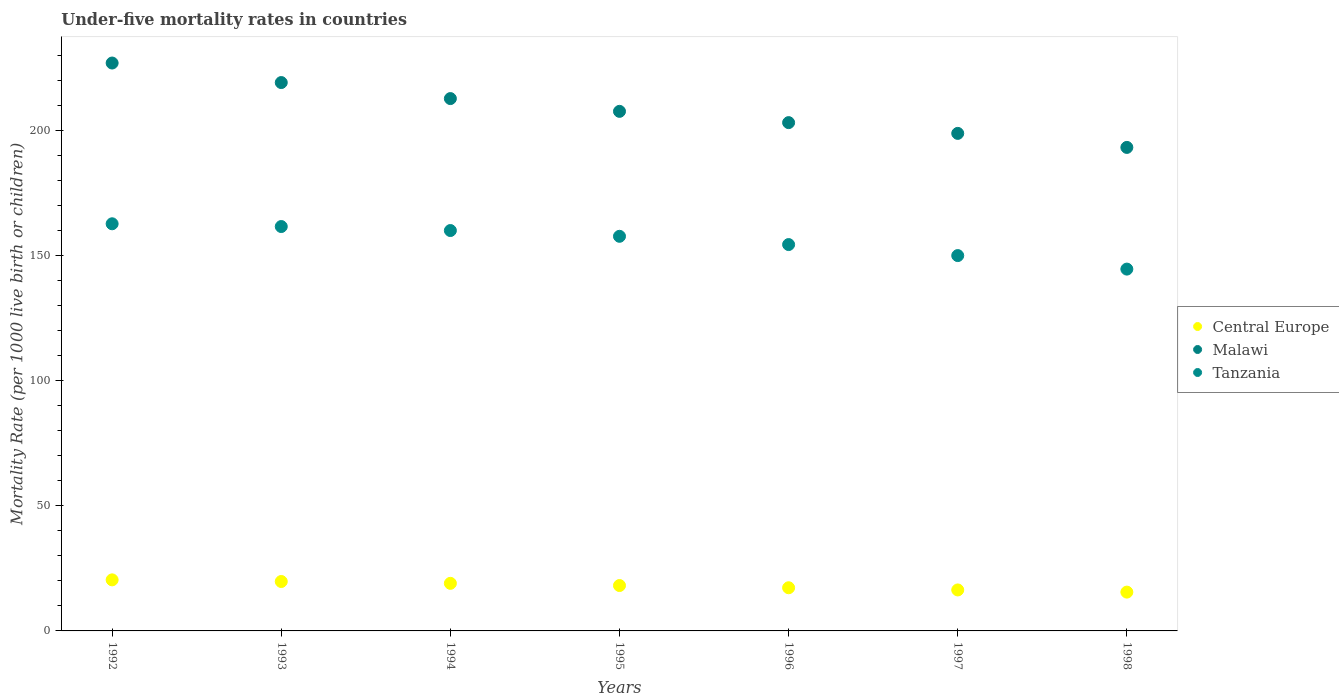How many different coloured dotlines are there?
Your answer should be very brief. 3. Is the number of dotlines equal to the number of legend labels?
Give a very brief answer. Yes. What is the under-five mortality rate in Central Europe in 1992?
Make the answer very short. 20.39. Across all years, what is the maximum under-five mortality rate in Tanzania?
Your answer should be very brief. 162.6. Across all years, what is the minimum under-five mortality rate in Tanzania?
Ensure brevity in your answer.  144.5. What is the total under-five mortality rate in Malawi in the graph?
Offer a very short reply. 1460.7. What is the difference between the under-five mortality rate in Central Europe in 1995 and that in 1996?
Keep it short and to the point. 0.89. What is the difference between the under-five mortality rate in Tanzania in 1997 and the under-five mortality rate in Malawi in 1996?
Your answer should be very brief. -53.1. What is the average under-five mortality rate in Tanzania per year?
Make the answer very short. 155.76. In the year 1995, what is the difference between the under-five mortality rate in Central Europe and under-five mortality rate in Malawi?
Your answer should be very brief. -189.37. In how many years, is the under-five mortality rate in Central Europe greater than 50?
Make the answer very short. 0. What is the ratio of the under-five mortality rate in Central Europe in 1995 to that in 1996?
Provide a succinct answer. 1.05. Is the difference between the under-five mortality rate in Central Europe in 1992 and 1998 greater than the difference between the under-five mortality rate in Malawi in 1992 and 1998?
Provide a succinct answer. No. What is the difference between the highest and the second highest under-five mortality rate in Malawi?
Keep it short and to the point. 7.8. What is the difference between the highest and the lowest under-five mortality rate in Central Europe?
Make the answer very short. 4.89. In how many years, is the under-five mortality rate in Malawi greater than the average under-five mortality rate in Malawi taken over all years?
Ensure brevity in your answer.  3. Is the sum of the under-five mortality rate in Tanzania in 1992 and 1994 greater than the maximum under-five mortality rate in Central Europe across all years?
Offer a terse response. Yes. Is the under-five mortality rate in Malawi strictly less than the under-five mortality rate in Central Europe over the years?
Make the answer very short. No. How many dotlines are there?
Your answer should be compact. 3. How many years are there in the graph?
Make the answer very short. 7. Does the graph contain any zero values?
Your answer should be very brief. No. What is the title of the graph?
Keep it short and to the point. Under-five mortality rates in countries. What is the label or title of the X-axis?
Your answer should be very brief. Years. What is the label or title of the Y-axis?
Keep it short and to the point. Mortality Rate (per 1000 live birth or children). What is the Mortality Rate (per 1000 live birth or children) in Central Europe in 1992?
Your answer should be compact. 20.39. What is the Mortality Rate (per 1000 live birth or children) in Malawi in 1992?
Make the answer very short. 226.8. What is the Mortality Rate (per 1000 live birth or children) in Tanzania in 1992?
Your answer should be compact. 162.6. What is the Mortality Rate (per 1000 live birth or children) in Central Europe in 1993?
Offer a terse response. 19.73. What is the Mortality Rate (per 1000 live birth or children) of Malawi in 1993?
Ensure brevity in your answer.  219. What is the Mortality Rate (per 1000 live birth or children) of Tanzania in 1993?
Provide a succinct answer. 161.5. What is the Mortality Rate (per 1000 live birth or children) in Central Europe in 1994?
Provide a short and direct response. 19. What is the Mortality Rate (per 1000 live birth or children) of Malawi in 1994?
Offer a terse response. 212.6. What is the Mortality Rate (per 1000 live birth or children) in Tanzania in 1994?
Make the answer very short. 159.9. What is the Mortality Rate (per 1000 live birth or children) in Central Europe in 1995?
Offer a very short reply. 18.13. What is the Mortality Rate (per 1000 live birth or children) of Malawi in 1995?
Keep it short and to the point. 207.5. What is the Mortality Rate (per 1000 live birth or children) in Tanzania in 1995?
Offer a terse response. 157.6. What is the Mortality Rate (per 1000 live birth or children) in Central Europe in 1996?
Ensure brevity in your answer.  17.24. What is the Mortality Rate (per 1000 live birth or children) of Malawi in 1996?
Offer a very short reply. 203. What is the Mortality Rate (per 1000 live birth or children) of Tanzania in 1996?
Provide a short and direct response. 154.3. What is the Mortality Rate (per 1000 live birth or children) of Central Europe in 1997?
Your answer should be very brief. 16.37. What is the Mortality Rate (per 1000 live birth or children) of Malawi in 1997?
Keep it short and to the point. 198.7. What is the Mortality Rate (per 1000 live birth or children) in Tanzania in 1997?
Give a very brief answer. 149.9. What is the Mortality Rate (per 1000 live birth or children) in Central Europe in 1998?
Give a very brief answer. 15.5. What is the Mortality Rate (per 1000 live birth or children) in Malawi in 1998?
Give a very brief answer. 193.1. What is the Mortality Rate (per 1000 live birth or children) of Tanzania in 1998?
Make the answer very short. 144.5. Across all years, what is the maximum Mortality Rate (per 1000 live birth or children) in Central Europe?
Offer a terse response. 20.39. Across all years, what is the maximum Mortality Rate (per 1000 live birth or children) in Malawi?
Keep it short and to the point. 226.8. Across all years, what is the maximum Mortality Rate (per 1000 live birth or children) of Tanzania?
Your answer should be very brief. 162.6. Across all years, what is the minimum Mortality Rate (per 1000 live birth or children) in Central Europe?
Your response must be concise. 15.5. Across all years, what is the minimum Mortality Rate (per 1000 live birth or children) in Malawi?
Keep it short and to the point. 193.1. Across all years, what is the minimum Mortality Rate (per 1000 live birth or children) in Tanzania?
Give a very brief answer. 144.5. What is the total Mortality Rate (per 1000 live birth or children) in Central Europe in the graph?
Make the answer very short. 126.36. What is the total Mortality Rate (per 1000 live birth or children) of Malawi in the graph?
Your answer should be very brief. 1460.7. What is the total Mortality Rate (per 1000 live birth or children) in Tanzania in the graph?
Your answer should be compact. 1090.3. What is the difference between the Mortality Rate (per 1000 live birth or children) of Central Europe in 1992 and that in 1993?
Provide a succinct answer. 0.66. What is the difference between the Mortality Rate (per 1000 live birth or children) in Malawi in 1992 and that in 1993?
Your answer should be compact. 7.8. What is the difference between the Mortality Rate (per 1000 live birth or children) in Tanzania in 1992 and that in 1993?
Provide a short and direct response. 1.1. What is the difference between the Mortality Rate (per 1000 live birth or children) of Central Europe in 1992 and that in 1994?
Your answer should be compact. 1.39. What is the difference between the Mortality Rate (per 1000 live birth or children) in Central Europe in 1992 and that in 1995?
Offer a terse response. 2.27. What is the difference between the Mortality Rate (per 1000 live birth or children) in Malawi in 1992 and that in 1995?
Keep it short and to the point. 19.3. What is the difference between the Mortality Rate (per 1000 live birth or children) in Central Europe in 1992 and that in 1996?
Give a very brief answer. 3.15. What is the difference between the Mortality Rate (per 1000 live birth or children) of Malawi in 1992 and that in 1996?
Your answer should be very brief. 23.8. What is the difference between the Mortality Rate (per 1000 live birth or children) in Tanzania in 1992 and that in 1996?
Keep it short and to the point. 8.3. What is the difference between the Mortality Rate (per 1000 live birth or children) in Central Europe in 1992 and that in 1997?
Ensure brevity in your answer.  4.03. What is the difference between the Mortality Rate (per 1000 live birth or children) in Malawi in 1992 and that in 1997?
Keep it short and to the point. 28.1. What is the difference between the Mortality Rate (per 1000 live birth or children) of Central Europe in 1992 and that in 1998?
Offer a terse response. 4.89. What is the difference between the Mortality Rate (per 1000 live birth or children) of Malawi in 1992 and that in 1998?
Ensure brevity in your answer.  33.7. What is the difference between the Mortality Rate (per 1000 live birth or children) of Central Europe in 1993 and that in 1994?
Make the answer very short. 0.73. What is the difference between the Mortality Rate (per 1000 live birth or children) of Tanzania in 1993 and that in 1994?
Ensure brevity in your answer.  1.6. What is the difference between the Mortality Rate (per 1000 live birth or children) of Central Europe in 1993 and that in 1995?
Offer a terse response. 1.61. What is the difference between the Mortality Rate (per 1000 live birth or children) of Malawi in 1993 and that in 1995?
Your answer should be very brief. 11.5. What is the difference between the Mortality Rate (per 1000 live birth or children) of Central Europe in 1993 and that in 1996?
Give a very brief answer. 2.5. What is the difference between the Mortality Rate (per 1000 live birth or children) in Central Europe in 1993 and that in 1997?
Your answer should be compact. 3.37. What is the difference between the Mortality Rate (per 1000 live birth or children) in Malawi in 1993 and that in 1997?
Ensure brevity in your answer.  20.3. What is the difference between the Mortality Rate (per 1000 live birth or children) in Tanzania in 1993 and that in 1997?
Your answer should be very brief. 11.6. What is the difference between the Mortality Rate (per 1000 live birth or children) of Central Europe in 1993 and that in 1998?
Offer a very short reply. 4.24. What is the difference between the Mortality Rate (per 1000 live birth or children) in Malawi in 1993 and that in 1998?
Your response must be concise. 25.9. What is the difference between the Mortality Rate (per 1000 live birth or children) of Central Europe in 1994 and that in 1995?
Ensure brevity in your answer.  0.88. What is the difference between the Mortality Rate (per 1000 live birth or children) in Tanzania in 1994 and that in 1995?
Your response must be concise. 2.3. What is the difference between the Mortality Rate (per 1000 live birth or children) of Central Europe in 1994 and that in 1996?
Your answer should be compact. 1.77. What is the difference between the Mortality Rate (per 1000 live birth or children) of Tanzania in 1994 and that in 1996?
Ensure brevity in your answer.  5.6. What is the difference between the Mortality Rate (per 1000 live birth or children) in Central Europe in 1994 and that in 1997?
Offer a terse response. 2.64. What is the difference between the Mortality Rate (per 1000 live birth or children) in Malawi in 1994 and that in 1997?
Give a very brief answer. 13.9. What is the difference between the Mortality Rate (per 1000 live birth or children) in Tanzania in 1994 and that in 1997?
Make the answer very short. 10. What is the difference between the Mortality Rate (per 1000 live birth or children) of Central Europe in 1994 and that in 1998?
Give a very brief answer. 3.5. What is the difference between the Mortality Rate (per 1000 live birth or children) in Malawi in 1994 and that in 1998?
Make the answer very short. 19.5. What is the difference between the Mortality Rate (per 1000 live birth or children) in Central Europe in 1995 and that in 1996?
Make the answer very short. 0.89. What is the difference between the Mortality Rate (per 1000 live birth or children) of Malawi in 1995 and that in 1996?
Provide a succinct answer. 4.5. What is the difference between the Mortality Rate (per 1000 live birth or children) of Tanzania in 1995 and that in 1996?
Provide a succinct answer. 3.3. What is the difference between the Mortality Rate (per 1000 live birth or children) in Central Europe in 1995 and that in 1997?
Provide a short and direct response. 1.76. What is the difference between the Mortality Rate (per 1000 live birth or children) of Central Europe in 1995 and that in 1998?
Give a very brief answer. 2.63. What is the difference between the Mortality Rate (per 1000 live birth or children) in Tanzania in 1995 and that in 1998?
Ensure brevity in your answer.  13.1. What is the difference between the Mortality Rate (per 1000 live birth or children) in Central Europe in 1996 and that in 1997?
Offer a terse response. 0.87. What is the difference between the Mortality Rate (per 1000 live birth or children) in Tanzania in 1996 and that in 1997?
Your response must be concise. 4.4. What is the difference between the Mortality Rate (per 1000 live birth or children) of Central Europe in 1996 and that in 1998?
Your answer should be very brief. 1.74. What is the difference between the Mortality Rate (per 1000 live birth or children) in Tanzania in 1996 and that in 1998?
Make the answer very short. 9.8. What is the difference between the Mortality Rate (per 1000 live birth or children) of Central Europe in 1997 and that in 1998?
Provide a short and direct response. 0.87. What is the difference between the Mortality Rate (per 1000 live birth or children) in Malawi in 1997 and that in 1998?
Provide a short and direct response. 5.6. What is the difference between the Mortality Rate (per 1000 live birth or children) of Tanzania in 1997 and that in 1998?
Offer a very short reply. 5.4. What is the difference between the Mortality Rate (per 1000 live birth or children) of Central Europe in 1992 and the Mortality Rate (per 1000 live birth or children) of Malawi in 1993?
Give a very brief answer. -198.61. What is the difference between the Mortality Rate (per 1000 live birth or children) in Central Europe in 1992 and the Mortality Rate (per 1000 live birth or children) in Tanzania in 1993?
Your response must be concise. -141.11. What is the difference between the Mortality Rate (per 1000 live birth or children) in Malawi in 1992 and the Mortality Rate (per 1000 live birth or children) in Tanzania in 1993?
Ensure brevity in your answer.  65.3. What is the difference between the Mortality Rate (per 1000 live birth or children) of Central Europe in 1992 and the Mortality Rate (per 1000 live birth or children) of Malawi in 1994?
Offer a very short reply. -192.21. What is the difference between the Mortality Rate (per 1000 live birth or children) of Central Europe in 1992 and the Mortality Rate (per 1000 live birth or children) of Tanzania in 1994?
Your response must be concise. -139.51. What is the difference between the Mortality Rate (per 1000 live birth or children) in Malawi in 1992 and the Mortality Rate (per 1000 live birth or children) in Tanzania in 1994?
Ensure brevity in your answer.  66.9. What is the difference between the Mortality Rate (per 1000 live birth or children) of Central Europe in 1992 and the Mortality Rate (per 1000 live birth or children) of Malawi in 1995?
Your response must be concise. -187.11. What is the difference between the Mortality Rate (per 1000 live birth or children) in Central Europe in 1992 and the Mortality Rate (per 1000 live birth or children) in Tanzania in 1995?
Provide a succinct answer. -137.21. What is the difference between the Mortality Rate (per 1000 live birth or children) in Malawi in 1992 and the Mortality Rate (per 1000 live birth or children) in Tanzania in 1995?
Provide a short and direct response. 69.2. What is the difference between the Mortality Rate (per 1000 live birth or children) of Central Europe in 1992 and the Mortality Rate (per 1000 live birth or children) of Malawi in 1996?
Your answer should be very brief. -182.61. What is the difference between the Mortality Rate (per 1000 live birth or children) of Central Europe in 1992 and the Mortality Rate (per 1000 live birth or children) of Tanzania in 1996?
Give a very brief answer. -133.91. What is the difference between the Mortality Rate (per 1000 live birth or children) of Malawi in 1992 and the Mortality Rate (per 1000 live birth or children) of Tanzania in 1996?
Keep it short and to the point. 72.5. What is the difference between the Mortality Rate (per 1000 live birth or children) in Central Europe in 1992 and the Mortality Rate (per 1000 live birth or children) in Malawi in 1997?
Offer a very short reply. -178.31. What is the difference between the Mortality Rate (per 1000 live birth or children) in Central Europe in 1992 and the Mortality Rate (per 1000 live birth or children) in Tanzania in 1997?
Your answer should be compact. -129.51. What is the difference between the Mortality Rate (per 1000 live birth or children) of Malawi in 1992 and the Mortality Rate (per 1000 live birth or children) of Tanzania in 1997?
Your response must be concise. 76.9. What is the difference between the Mortality Rate (per 1000 live birth or children) in Central Europe in 1992 and the Mortality Rate (per 1000 live birth or children) in Malawi in 1998?
Your response must be concise. -172.71. What is the difference between the Mortality Rate (per 1000 live birth or children) of Central Europe in 1992 and the Mortality Rate (per 1000 live birth or children) of Tanzania in 1998?
Your answer should be very brief. -124.11. What is the difference between the Mortality Rate (per 1000 live birth or children) of Malawi in 1992 and the Mortality Rate (per 1000 live birth or children) of Tanzania in 1998?
Keep it short and to the point. 82.3. What is the difference between the Mortality Rate (per 1000 live birth or children) of Central Europe in 1993 and the Mortality Rate (per 1000 live birth or children) of Malawi in 1994?
Your answer should be very brief. -192.87. What is the difference between the Mortality Rate (per 1000 live birth or children) in Central Europe in 1993 and the Mortality Rate (per 1000 live birth or children) in Tanzania in 1994?
Your response must be concise. -140.17. What is the difference between the Mortality Rate (per 1000 live birth or children) of Malawi in 1993 and the Mortality Rate (per 1000 live birth or children) of Tanzania in 1994?
Your response must be concise. 59.1. What is the difference between the Mortality Rate (per 1000 live birth or children) of Central Europe in 1993 and the Mortality Rate (per 1000 live birth or children) of Malawi in 1995?
Offer a terse response. -187.77. What is the difference between the Mortality Rate (per 1000 live birth or children) in Central Europe in 1993 and the Mortality Rate (per 1000 live birth or children) in Tanzania in 1995?
Your answer should be very brief. -137.87. What is the difference between the Mortality Rate (per 1000 live birth or children) in Malawi in 1993 and the Mortality Rate (per 1000 live birth or children) in Tanzania in 1995?
Keep it short and to the point. 61.4. What is the difference between the Mortality Rate (per 1000 live birth or children) in Central Europe in 1993 and the Mortality Rate (per 1000 live birth or children) in Malawi in 1996?
Give a very brief answer. -183.27. What is the difference between the Mortality Rate (per 1000 live birth or children) in Central Europe in 1993 and the Mortality Rate (per 1000 live birth or children) in Tanzania in 1996?
Give a very brief answer. -134.57. What is the difference between the Mortality Rate (per 1000 live birth or children) in Malawi in 1993 and the Mortality Rate (per 1000 live birth or children) in Tanzania in 1996?
Provide a short and direct response. 64.7. What is the difference between the Mortality Rate (per 1000 live birth or children) in Central Europe in 1993 and the Mortality Rate (per 1000 live birth or children) in Malawi in 1997?
Your answer should be compact. -178.97. What is the difference between the Mortality Rate (per 1000 live birth or children) in Central Europe in 1993 and the Mortality Rate (per 1000 live birth or children) in Tanzania in 1997?
Your answer should be compact. -130.17. What is the difference between the Mortality Rate (per 1000 live birth or children) of Malawi in 1993 and the Mortality Rate (per 1000 live birth or children) of Tanzania in 1997?
Provide a succinct answer. 69.1. What is the difference between the Mortality Rate (per 1000 live birth or children) in Central Europe in 1993 and the Mortality Rate (per 1000 live birth or children) in Malawi in 1998?
Ensure brevity in your answer.  -173.37. What is the difference between the Mortality Rate (per 1000 live birth or children) in Central Europe in 1993 and the Mortality Rate (per 1000 live birth or children) in Tanzania in 1998?
Give a very brief answer. -124.77. What is the difference between the Mortality Rate (per 1000 live birth or children) of Malawi in 1993 and the Mortality Rate (per 1000 live birth or children) of Tanzania in 1998?
Make the answer very short. 74.5. What is the difference between the Mortality Rate (per 1000 live birth or children) of Central Europe in 1994 and the Mortality Rate (per 1000 live birth or children) of Malawi in 1995?
Offer a very short reply. -188.5. What is the difference between the Mortality Rate (per 1000 live birth or children) of Central Europe in 1994 and the Mortality Rate (per 1000 live birth or children) of Tanzania in 1995?
Your answer should be compact. -138.6. What is the difference between the Mortality Rate (per 1000 live birth or children) in Malawi in 1994 and the Mortality Rate (per 1000 live birth or children) in Tanzania in 1995?
Your response must be concise. 55. What is the difference between the Mortality Rate (per 1000 live birth or children) of Central Europe in 1994 and the Mortality Rate (per 1000 live birth or children) of Malawi in 1996?
Your answer should be very brief. -184. What is the difference between the Mortality Rate (per 1000 live birth or children) of Central Europe in 1994 and the Mortality Rate (per 1000 live birth or children) of Tanzania in 1996?
Keep it short and to the point. -135.3. What is the difference between the Mortality Rate (per 1000 live birth or children) in Malawi in 1994 and the Mortality Rate (per 1000 live birth or children) in Tanzania in 1996?
Your response must be concise. 58.3. What is the difference between the Mortality Rate (per 1000 live birth or children) of Central Europe in 1994 and the Mortality Rate (per 1000 live birth or children) of Malawi in 1997?
Give a very brief answer. -179.7. What is the difference between the Mortality Rate (per 1000 live birth or children) of Central Europe in 1994 and the Mortality Rate (per 1000 live birth or children) of Tanzania in 1997?
Your answer should be compact. -130.9. What is the difference between the Mortality Rate (per 1000 live birth or children) of Malawi in 1994 and the Mortality Rate (per 1000 live birth or children) of Tanzania in 1997?
Your response must be concise. 62.7. What is the difference between the Mortality Rate (per 1000 live birth or children) in Central Europe in 1994 and the Mortality Rate (per 1000 live birth or children) in Malawi in 1998?
Provide a succinct answer. -174.1. What is the difference between the Mortality Rate (per 1000 live birth or children) of Central Europe in 1994 and the Mortality Rate (per 1000 live birth or children) of Tanzania in 1998?
Make the answer very short. -125.5. What is the difference between the Mortality Rate (per 1000 live birth or children) of Malawi in 1994 and the Mortality Rate (per 1000 live birth or children) of Tanzania in 1998?
Give a very brief answer. 68.1. What is the difference between the Mortality Rate (per 1000 live birth or children) of Central Europe in 1995 and the Mortality Rate (per 1000 live birth or children) of Malawi in 1996?
Give a very brief answer. -184.87. What is the difference between the Mortality Rate (per 1000 live birth or children) in Central Europe in 1995 and the Mortality Rate (per 1000 live birth or children) in Tanzania in 1996?
Keep it short and to the point. -136.17. What is the difference between the Mortality Rate (per 1000 live birth or children) of Malawi in 1995 and the Mortality Rate (per 1000 live birth or children) of Tanzania in 1996?
Ensure brevity in your answer.  53.2. What is the difference between the Mortality Rate (per 1000 live birth or children) of Central Europe in 1995 and the Mortality Rate (per 1000 live birth or children) of Malawi in 1997?
Give a very brief answer. -180.57. What is the difference between the Mortality Rate (per 1000 live birth or children) of Central Europe in 1995 and the Mortality Rate (per 1000 live birth or children) of Tanzania in 1997?
Keep it short and to the point. -131.77. What is the difference between the Mortality Rate (per 1000 live birth or children) of Malawi in 1995 and the Mortality Rate (per 1000 live birth or children) of Tanzania in 1997?
Keep it short and to the point. 57.6. What is the difference between the Mortality Rate (per 1000 live birth or children) of Central Europe in 1995 and the Mortality Rate (per 1000 live birth or children) of Malawi in 1998?
Your answer should be very brief. -174.97. What is the difference between the Mortality Rate (per 1000 live birth or children) of Central Europe in 1995 and the Mortality Rate (per 1000 live birth or children) of Tanzania in 1998?
Your answer should be very brief. -126.37. What is the difference between the Mortality Rate (per 1000 live birth or children) in Malawi in 1995 and the Mortality Rate (per 1000 live birth or children) in Tanzania in 1998?
Keep it short and to the point. 63. What is the difference between the Mortality Rate (per 1000 live birth or children) in Central Europe in 1996 and the Mortality Rate (per 1000 live birth or children) in Malawi in 1997?
Ensure brevity in your answer.  -181.46. What is the difference between the Mortality Rate (per 1000 live birth or children) in Central Europe in 1996 and the Mortality Rate (per 1000 live birth or children) in Tanzania in 1997?
Provide a short and direct response. -132.66. What is the difference between the Mortality Rate (per 1000 live birth or children) in Malawi in 1996 and the Mortality Rate (per 1000 live birth or children) in Tanzania in 1997?
Offer a terse response. 53.1. What is the difference between the Mortality Rate (per 1000 live birth or children) in Central Europe in 1996 and the Mortality Rate (per 1000 live birth or children) in Malawi in 1998?
Provide a short and direct response. -175.86. What is the difference between the Mortality Rate (per 1000 live birth or children) in Central Europe in 1996 and the Mortality Rate (per 1000 live birth or children) in Tanzania in 1998?
Ensure brevity in your answer.  -127.26. What is the difference between the Mortality Rate (per 1000 live birth or children) in Malawi in 1996 and the Mortality Rate (per 1000 live birth or children) in Tanzania in 1998?
Provide a succinct answer. 58.5. What is the difference between the Mortality Rate (per 1000 live birth or children) in Central Europe in 1997 and the Mortality Rate (per 1000 live birth or children) in Malawi in 1998?
Give a very brief answer. -176.73. What is the difference between the Mortality Rate (per 1000 live birth or children) in Central Europe in 1997 and the Mortality Rate (per 1000 live birth or children) in Tanzania in 1998?
Ensure brevity in your answer.  -128.13. What is the difference between the Mortality Rate (per 1000 live birth or children) of Malawi in 1997 and the Mortality Rate (per 1000 live birth or children) of Tanzania in 1998?
Offer a very short reply. 54.2. What is the average Mortality Rate (per 1000 live birth or children) in Central Europe per year?
Offer a terse response. 18.05. What is the average Mortality Rate (per 1000 live birth or children) of Malawi per year?
Ensure brevity in your answer.  208.67. What is the average Mortality Rate (per 1000 live birth or children) in Tanzania per year?
Provide a succinct answer. 155.76. In the year 1992, what is the difference between the Mortality Rate (per 1000 live birth or children) in Central Europe and Mortality Rate (per 1000 live birth or children) in Malawi?
Ensure brevity in your answer.  -206.41. In the year 1992, what is the difference between the Mortality Rate (per 1000 live birth or children) of Central Europe and Mortality Rate (per 1000 live birth or children) of Tanzania?
Your response must be concise. -142.21. In the year 1992, what is the difference between the Mortality Rate (per 1000 live birth or children) of Malawi and Mortality Rate (per 1000 live birth or children) of Tanzania?
Your answer should be very brief. 64.2. In the year 1993, what is the difference between the Mortality Rate (per 1000 live birth or children) in Central Europe and Mortality Rate (per 1000 live birth or children) in Malawi?
Your answer should be compact. -199.27. In the year 1993, what is the difference between the Mortality Rate (per 1000 live birth or children) of Central Europe and Mortality Rate (per 1000 live birth or children) of Tanzania?
Make the answer very short. -141.77. In the year 1993, what is the difference between the Mortality Rate (per 1000 live birth or children) in Malawi and Mortality Rate (per 1000 live birth or children) in Tanzania?
Provide a succinct answer. 57.5. In the year 1994, what is the difference between the Mortality Rate (per 1000 live birth or children) of Central Europe and Mortality Rate (per 1000 live birth or children) of Malawi?
Offer a very short reply. -193.6. In the year 1994, what is the difference between the Mortality Rate (per 1000 live birth or children) of Central Europe and Mortality Rate (per 1000 live birth or children) of Tanzania?
Offer a very short reply. -140.9. In the year 1994, what is the difference between the Mortality Rate (per 1000 live birth or children) in Malawi and Mortality Rate (per 1000 live birth or children) in Tanzania?
Ensure brevity in your answer.  52.7. In the year 1995, what is the difference between the Mortality Rate (per 1000 live birth or children) in Central Europe and Mortality Rate (per 1000 live birth or children) in Malawi?
Offer a very short reply. -189.37. In the year 1995, what is the difference between the Mortality Rate (per 1000 live birth or children) of Central Europe and Mortality Rate (per 1000 live birth or children) of Tanzania?
Give a very brief answer. -139.47. In the year 1995, what is the difference between the Mortality Rate (per 1000 live birth or children) in Malawi and Mortality Rate (per 1000 live birth or children) in Tanzania?
Give a very brief answer. 49.9. In the year 1996, what is the difference between the Mortality Rate (per 1000 live birth or children) in Central Europe and Mortality Rate (per 1000 live birth or children) in Malawi?
Ensure brevity in your answer.  -185.76. In the year 1996, what is the difference between the Mortality Rate (per 1000 live birth or children) in Central Europe and Mortality Rate (per 1000 live birth or children) in Tanzania?
Offer a terse response. -137.06. In the year 1996, what is the difference between the Mortality Rate (per 1000 live birth or children) of Malawi and Mortality Rate (per 1000 live birth or children) of Tanzania?
Offer a very short reply. 48.7. In the year 1997, what is the difference between the Mortality Rate (per 1000 live birth or children) in Central Europe and Mortality Rate (per 1000 live birth or children) in Malawi?
Your answer should be very brief. -182.33. In the year 1997, what is the difference between the Mortality Rate (per 1000 live birth or children) of Central Europe and Mortality Rate (per 1000 live birth or children) of Tanzania?
Your response must be concise. -133.53. In the year 1997, what is the difference between the Mortality Rate (per 1000 live birth or children) of Malawi and Mortality Rate (per 1000 live birth or children) of Tanzania?
Provide a succinct answer. 48.8. In the year 1998, what is the difference between the Mortality Rate (per 1000 live birth or children) in Central Europe and Mortality Rate (per 1000 live birth or children) in Malawi?
Your answer should be very brief. -177.6. In the year 1998, what is the difference between the Mortality Rate (per 1000 live birth or children) in Central Europe and Mortality Rate (per 1000 live birth or children) in Tanzania?
Offer a very short reply. -129. In the year 1998, what is the difference between the Mortality Rate (per 1000 live birth or children) of Malawi and Mortality Rate (per 1000 live birth or children) of Tanzania?
Provide a short and direct response. 48.6. What is the ratio of the Mortality Rate (per 1000 live birth or children) of Malawi in 1992 to that in 1993?
Your answer should be very brief. 1.04. What is the ratio of the Mortality Rate (per 1000 live birth or children) of Tanzania in 1992 to that in 1993?
Ensure brevity in your answer.  1.01. What is the ratio of the Mortality Rate (per 1000 live birth or children) of Central Europe in 1992 to that in 1994?
Your answer should be very brief. 1.07. What is the ratio of the Mortality Rate (per 1000 live birth or children) of Malawi in 1992 to that in 1994?
Offer a very short reply. 1.07. What is the ratio of the Mortality Rate (per 1000 live birth or children) in Tanzania in 1992 to that in 1994?
Make the answer very short. 1.02. What is the ratio of the Mortality Rate (per 1000 live birth or children) of Malawi in 1992 to that in 1995?
Your response must be concise. 1.09. What is the ratio of the Mortality Rate (per 1000 live birth or children) in Tanzania in 1992 to that in 1995?
Offer a very short reply. 1.03. What is the ratio of the Mortality Rate (per 1000 live birth or children) in Central Europe in 1992 to that in 1996?
Give a very brief answer. 1.18. What is the ratio of the Mortality Rate (per 1000 live birth or children) of Malawi in 1992 to that in 1996?
Give a very brief answer. 1.12. What is the ratio of the Mortality Rate (per 1000 live birth or children) of Tanzania in 1992 to that in 1996?
Your answer should be very brief. 1.05. What is the ratio of the Mortality Rate (per 1000 live birth or children) in Central Europe in 1992 to that in 1997?
Your response must be concise. 1.25. What is the ratio of the Mortality Rate (per 1000 live birth or children) of Malawi in 1992 to that in 1997?
Make the answer very short. 1.14. What is the ratio of the Mortality Rate (per 1000 live birth or children) of Tanzania in 1992 to that in 1997?
Your answer should be very brief. 1.08. What is the ratio of the Mortality Rate (per 1000 live birth or children) of Central Europe in 1992 to that in 1998?
Your response must be concise. 1.32. What is the ratio of the Mortality Rate (per 1000 live birth or children) in Malawi in 1992 to that in 1998?
Your answer should be compact. 1.17. What is the ratio of the Mortality Rate (per 1000 live birth or children) in Tanzania in 1992 to that in 1998?
Provide a short and direct response. 1.13. What is the ratio of the Mortality Rate (per 1000 live birth or children) in Malawi in 1993 to that in 1994?
Make the answer very short. 1.03. What is the ratio of the Mortality Rate (per 1000 live birth or children) in Tanzania in 1993 to that in 1994?
Keep it short and to the point. 1.01. What is the ratio of the Mortality Rate (per 1000 live birth or children) in Central Europe in 1993 to that in 1995?
Ensure brevity in your answer.  1.09. What is the ratio of the Mortality Rate (per 1000 live birth or children) in Malawi in 1993 to that in 1995?
Provide a succinct answer. 1.06. What is the ratio of the Mortality Rate (per 1000 live birth or children) in Tanzania in 1993 to that in 1995?
Ensure brevity in your answer.  1.02. What is the ratio of the Mortality Rate (per 1000 live birth or children) of Central Europe in 1993 to that in 1996?
Offer a very short reply. 1.14. What is the ratio of the Mortality Rate (per 1000 live birth or children) of Malawi in 1993 to that in 1996?
Offer a terse response. 1.08. What is the ratio of the Mortality Rate (per 1000 live birth or children) in Tanzania in 1993 to that in 1996?
Your answer should be very brief. 1.05. What is the ratio of the Mortality Rate (per 1000 live birth or children) of Central Europe in 1993 to that in 1997?
Your answer should be compact. 1.21. What is the ratio of the Mortality Rate (per 1000 live birth or children) of Malawi in 1993 to that in 1997?
Your answer should be very brief. 1.1. What is the ratio of the Mortality Rate (per 1000 live birth or children) of Tanzania in 1993 to that in 1997?
Make the answer very short. 1.08. What is the ratio of the Mortality Rate (per 1000 live birth or children) of Central Europe in 1993 to that in 1998?
Provide a succinct answer. 1.27. What is the ratio of the Mortality Rate (per 1000 live birth or children) of Malawi in 1993 to that in 1998?
Make the answer very short. 1.13. What is the ratio of the Mortality Rate (per 1000 live birth or children) of Tanzania in 1993 to that in 1998?
Your response must be concise. 1.12. What is the ratio of the Mortality Rate (per 1000 live birth or children) of Central Europe in 1994 to that in 1995?
Make the answer very short. 1.05. What is the ratio of the Mortality Rate (per 1000 live birth or children) of Malawi in 1994 to that in 1995?
Give a very brief answer. 1.02. What is the ratio of the Mortality Rate (per 1000 live birth or children) in Tanzania in 1994 to that in 1995?
Ensure brevity in your answer.  1.01. What is the ratio of the Mortality Rate (per 1000 live birth or children) of Central Europe in 1994 to that in 1996?
Offer a terse response. 1.1. What is the ratio of the Mortality Rate (per 1000 live birth or children) of Malawi in 1994 to that in 1996?
Offer a terse response. 1.05. What is the ratio of the Mortality Rate (per 1000 live birth or children) in Tanzania in 1994 to that in 1996?
Your response must be concise. 1.04. What is the ratio of the Mortality Rate (per 1000 live birth or children) of Central Europe in 1994 to that in 1997?
Make the answer very short. 1.16. What is the ratio of the Mortality Rate (per 1000 live birth or children) in Malawi in 1994 to that in 1997?
Keep it short and to the point. 1.07. What is the ratio of the Mortality Rate (per 1000 live birth or children) in Tanzania in 1994 to that in 1997?
Your answer should be very brief. 1.07. What is the ratio of the Mortality Rate (per 1000 live birth or children) in Central Europe in 1994 to that in 1998?
Offer a very short reply. 1.23. What is the ratio of the Mortality Rate (per 1000 live birth or children) of Malawi in 1994 to that in 1998?
Give a very brief answer. 1.1. What is the ratio of the Mortality Rate (per 1000 live birth or children) of Tanzania in 1994 to that in 1998?
Offer a very short reply. 1.11. What is the ratio of the Mortality Rate (per 1000 live birth or children) of Central Europe in 1995 to that in 1996?
Ensure brevity in your answer.  1.05. What is the ratio of the Mortality Rate (per 1000 live birth or children) in Malawi in 1995 to that in 1996?
Your response must be concise. 1.02. What is the ratio of the Mortality Rate (per 1000 live birth or children) in Tanzania in 1995 to that in 1996?
Offer a very short reply. 1.02. What is the ratio of the Mortality Rate (per 1000 live birth or children) of Central Europe in 1995 to that in 1997?
Your response must be concise. 1.11. What is the ratio of the Mortality Rate (per 1000 live birth or children) in Malawi in 1995 to that in 1997?
Your response must be concise. 1.04. What is the ratio of the Mortality Rate (per 1000 live birth or children) in Tanzania in 1995 to that in 1997?
Make the answer very short. 1.05. What is the ratio of the Mortality Rate (per 1000 live birth or children) in Central Europe in 1995 to that in 1998?
Your response must be concise. 1.17. What is the ratio of the Mortality Rate (per 1000 live birth or children) of Malawi in 1995 to that in 1998?
Provide a succinct answer. 1.07. What is the ratio of the Mortality Rate (per 1000 live birth or children) in Tanzania in 1995 to that in 1998?
Your answer should be compact. 1.09. What is the ratio of the Mortality Rate (per 1000 live birth or children) in Central Europe in 1996 to that in 1997?
Your answer should be compact. 1.05. What is the ratio of the Mortality Rate (per 1000 live birth or children) of Malawi in 1996 to that in 1997?
Your answer should be compact. 1.02. What is the ratio of the Mortality Rate (per 1000 live birth or children) in Tanzania in 1996 to that in 1997?
Your answer should be compact. 1.03. What is the ratio of the Mortality Rate (per 1000 live birth or children) in Central Europe in 1996 to that in 1998?
Your answer should be compact. 1.11. What is the ratio of the Mortality Rate (per 1000 live birth or children) in Malawi in 1996 to that in 1998?
Your answer should be very brief. 1.05. What is the ratio of the Mortality Rate (per 1000 live birth or children) in Tanzania in 1996 to that in 1998?
Your answer should be very brief. 1.07. What is the ratio of the Mortality Rate (per 1000 live birth or children) in Central Europe in 1997 to that in 1998?
Your answer should be compact. 1.06. What is the ratio of the Mortality Rate (per 1000 live birth or children) in Malawi in 1997 to that in 1998?
Keep it short and to the point. 1.03. What is the ratio of the Mortality Rate (per 1000 live birth or children) in Tanzania in 1997 to that in 1998?
Offer a very short reply. 1.04. What is the difference between the highest and the second highest Mortality Rate (per 1000 live birth or children) in Central Europe?
Keep it short and to the point. 0.66. What is the difference between the highest and the lowest Mortality Rate (per 1000 live birth or children) of Central Europe?
Offer a terse response. 4.89. What is the difference between the highest and the lowest Mortality Rate (per 1000 live birth or children) of Malawi?
Provide a succinct answer. 33.7. 